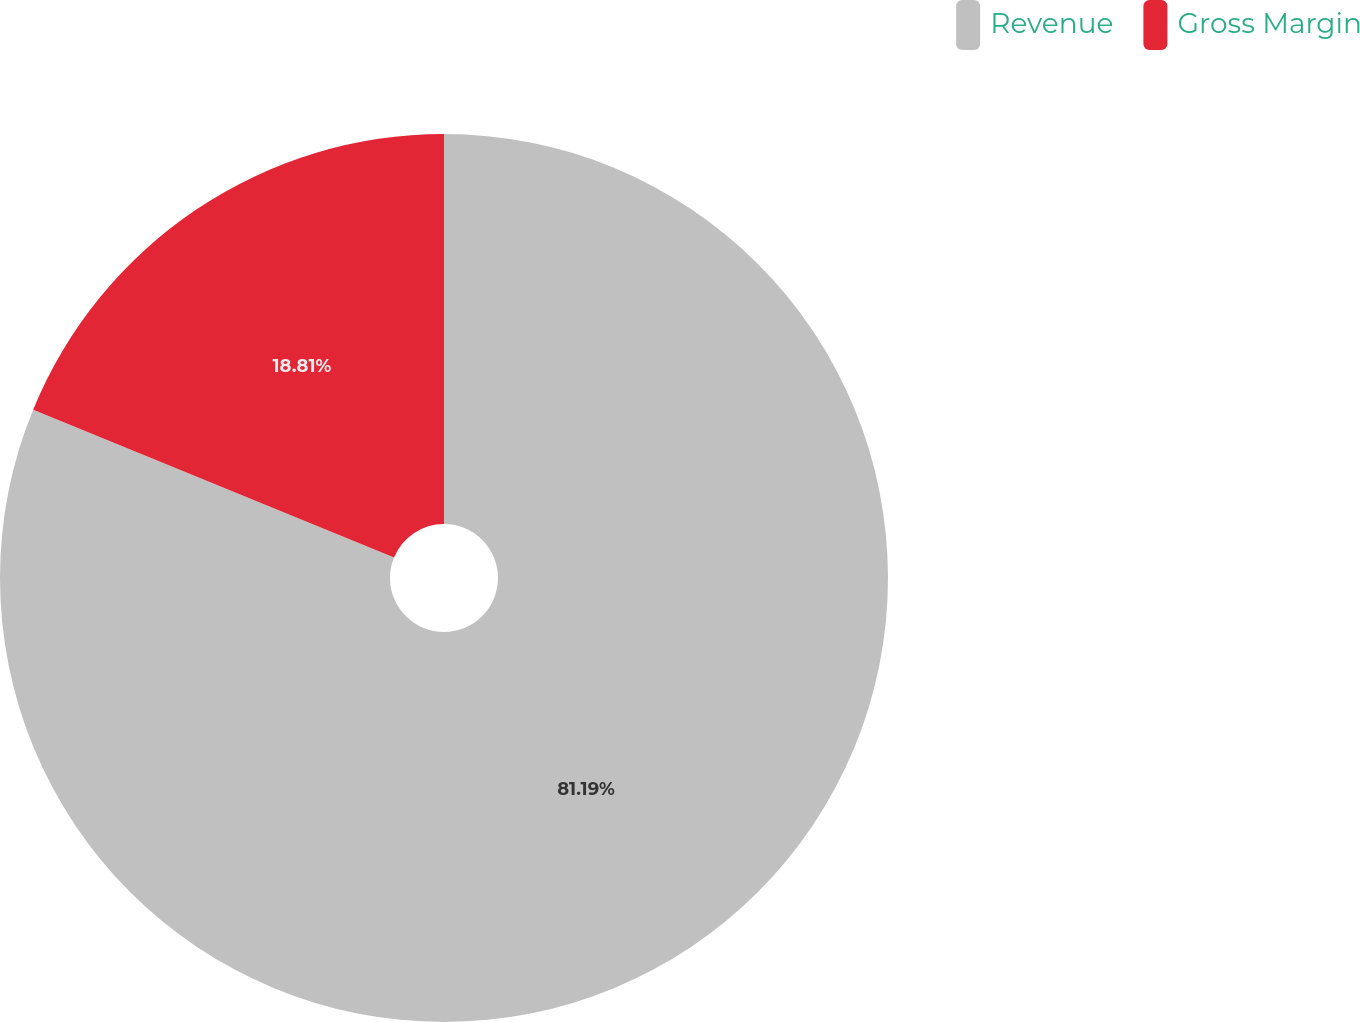<chart> <loc_0><loc_0><loc_500><loc_500><pie_chart><fcel>Revenue<fcel>Gross Margin<nl><fcel>81.19%<fcel>18.81%<nl></chart> 